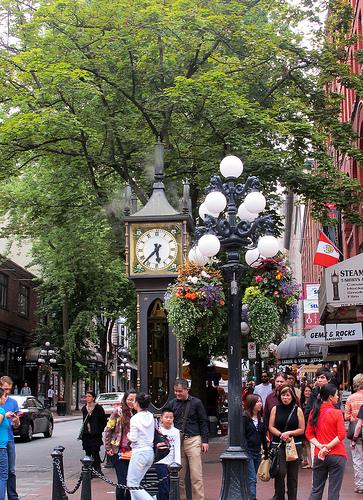Question: when is the picture taken?
Choices:
A. Morning.
B. Evening.
C. Night time.
D. Afternoon.
Answer with the letter. Answer: D Question: who is holding the paperbag?
Choices:
A. The man.
B. A child.
C. The teacher.
D. The woman.
Answer with the letter. Answer: D Question: why is the tower there?
Choices:
A. For cell signal.
B. For radio reception.
C. To mark a historical location.
D. Clock.
Answer with the letter. Answer: D Question: what time is it?
Choices:
A. Six nineteen.
B. Five thirty seven.
C. Noon.
D. One twenty three.
Answer with the letter. Answer: B Question: what is on the light pole?
Choices:
A. A bird.
B. Flowers.
C. Weeds.
D. A broken light.
Answer with the letter. Answer: B 